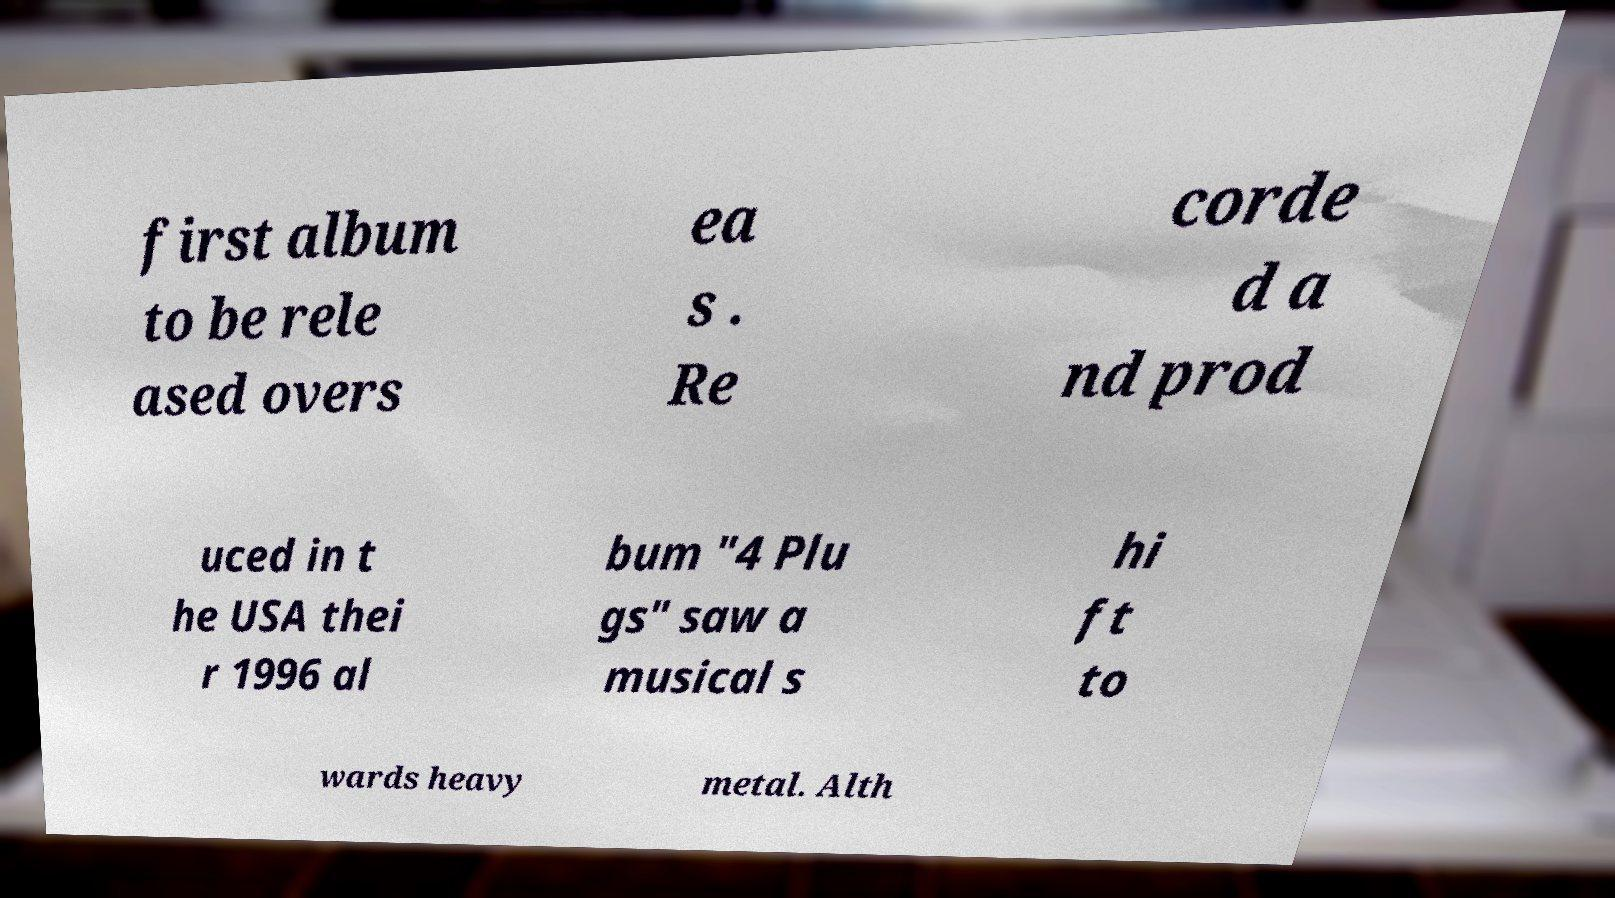Could you assist in decoding the text presented in this image and type it out clearly? first album to be rele ased overs ea s . Re corde d a nd prod uced in t he USA thei r 1996 al bum "4 Plu gs" saw a musical s hi ft to wards heavy metal. Alth 